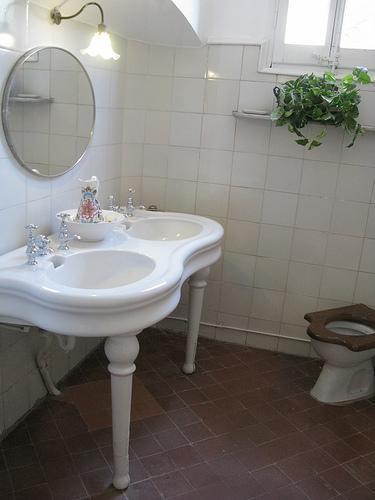How many sinks are there?
Give a very brief answer. 2. How many sinks are there?
Give a very brief answer. 2. How many potted plants are there?
Give a very brief answer. 1. 